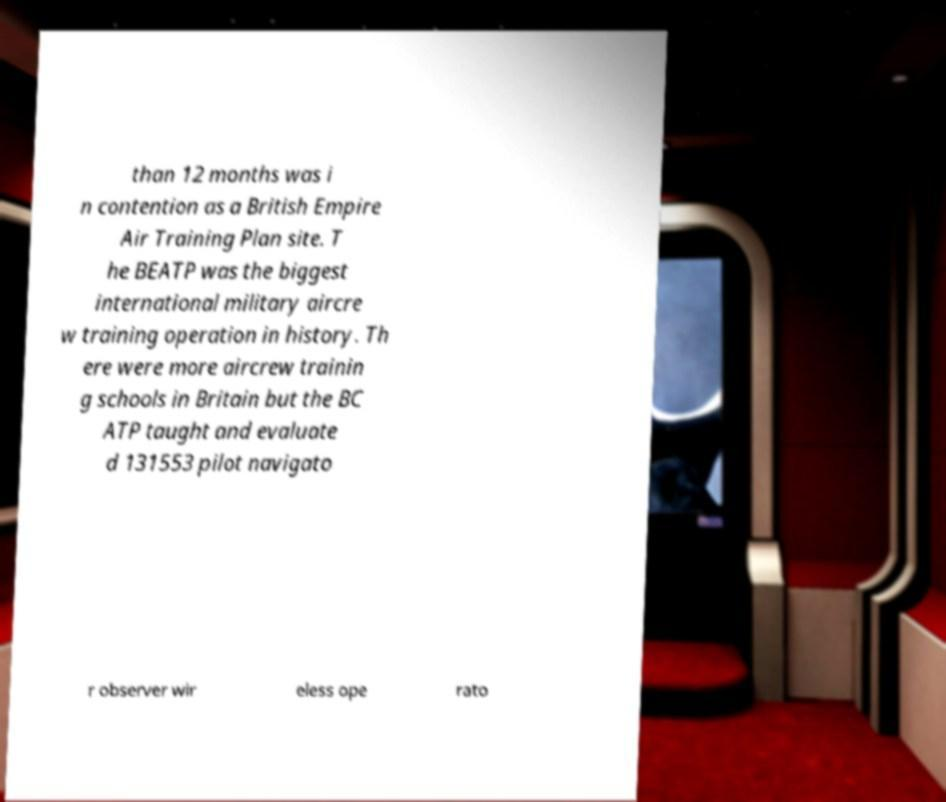There's text embedded in this image that I need extracted. Can you transcribe it verbatim? than 12 months was i n contention as a British Empire Air Training Plan site. T he BEATP was the biggest international military aircre w training operation in history. Th ere were more aircrew trainin g schools in Britain but the BC ATP taught and evaluate d 131553 pilot navigato r observer wir eless ope rato 